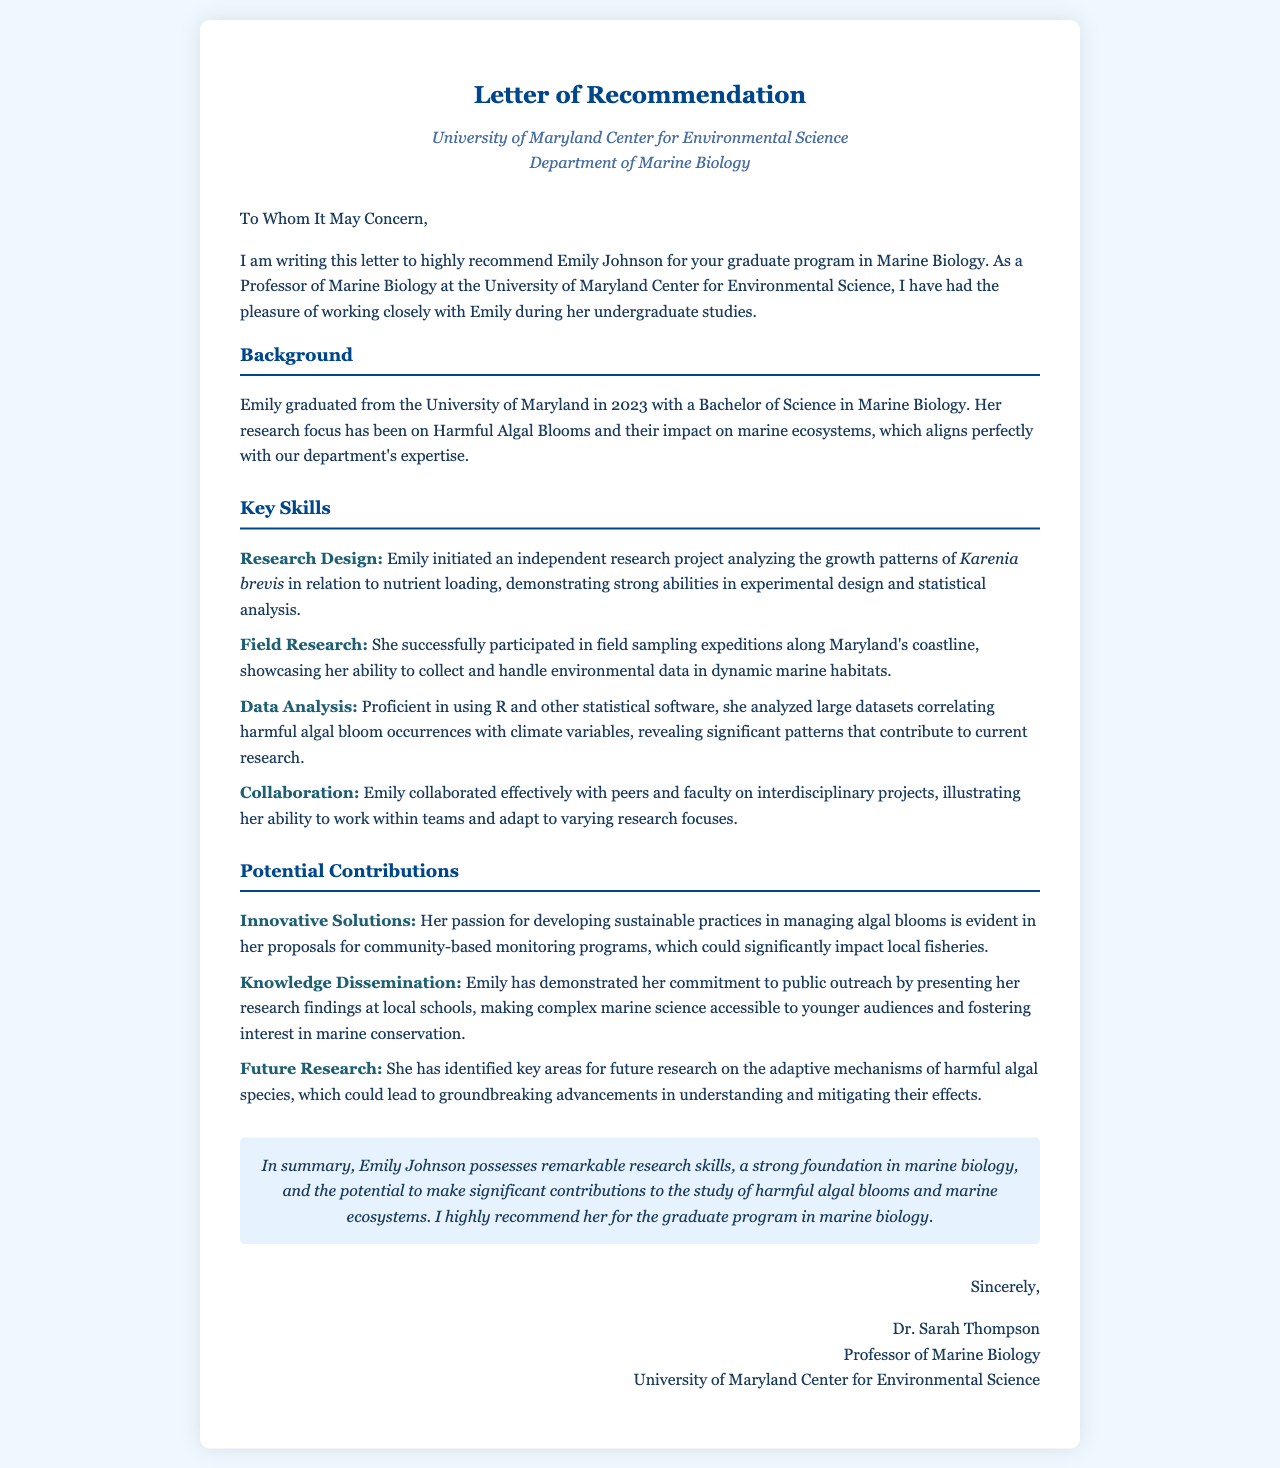What is the name of the student being recommended? The letter states that the name of the student is Emily Johnson.
Answer: Emily Johnson What is the degree Emily graduated with? The document specifies that Emily graduated with a Bachelor of Science in Marine Biology.
Answer: Bachelor of Science in Marine Biology What year did Emily graduate? The letter mentions that Emily graduated in 2023.
Answer: 2023 What specific area of research has Emily focused on? The document indicates that Emily's research focus has been on Harmful Algal Blooms and their impact on marine ecosystems.
Answer: Harmful Algal Blooms Which software is Emily proficient in for data analysis? The letter specifies that Emily is proficient in using R and other statistical software for data analysis.
Answer: R What type of programs has Emily proposed for managing algal blooms? The document states that she has proposed community-based monitoring programs.
Answer: community-based monitoring programs What type of outreach has Emily engaged in? The letter highlights that Emily has presented her research findings at local schools.
Answer: presented her research findings at local schools How does the recommender describe Emily's collaboration skills? The document notes that Emily collaborated effectively with peers and faculty on interdisciplinary projects.
Answer: collaborated effectively What is emphasized about Emily's research potential? The letter mentions that she has identified key areas for future research on the adaptive mechanisms of harmful algal species.
Answer: future research on the adaptive mechanisms of harmful algal species 